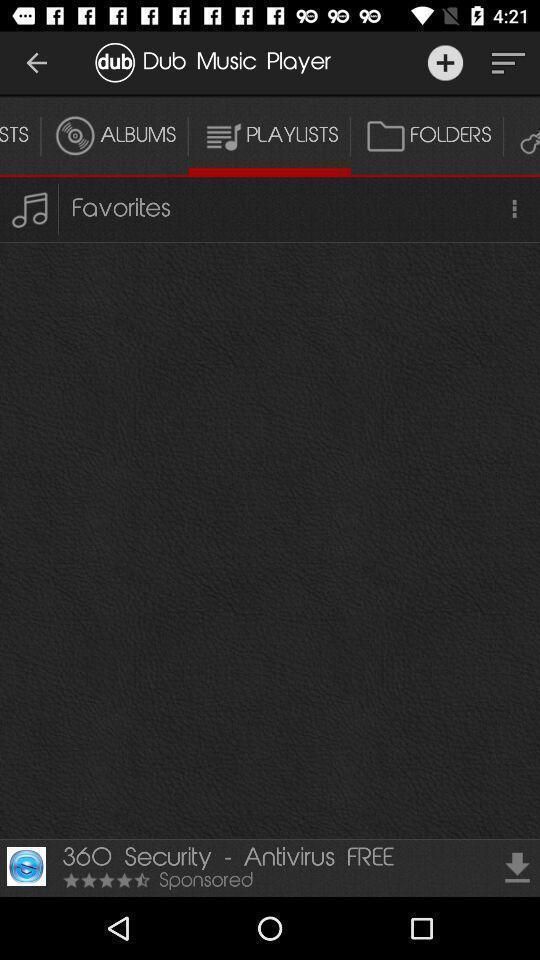What is the overall content of this screenshot? Screen displaying the playlist page. 